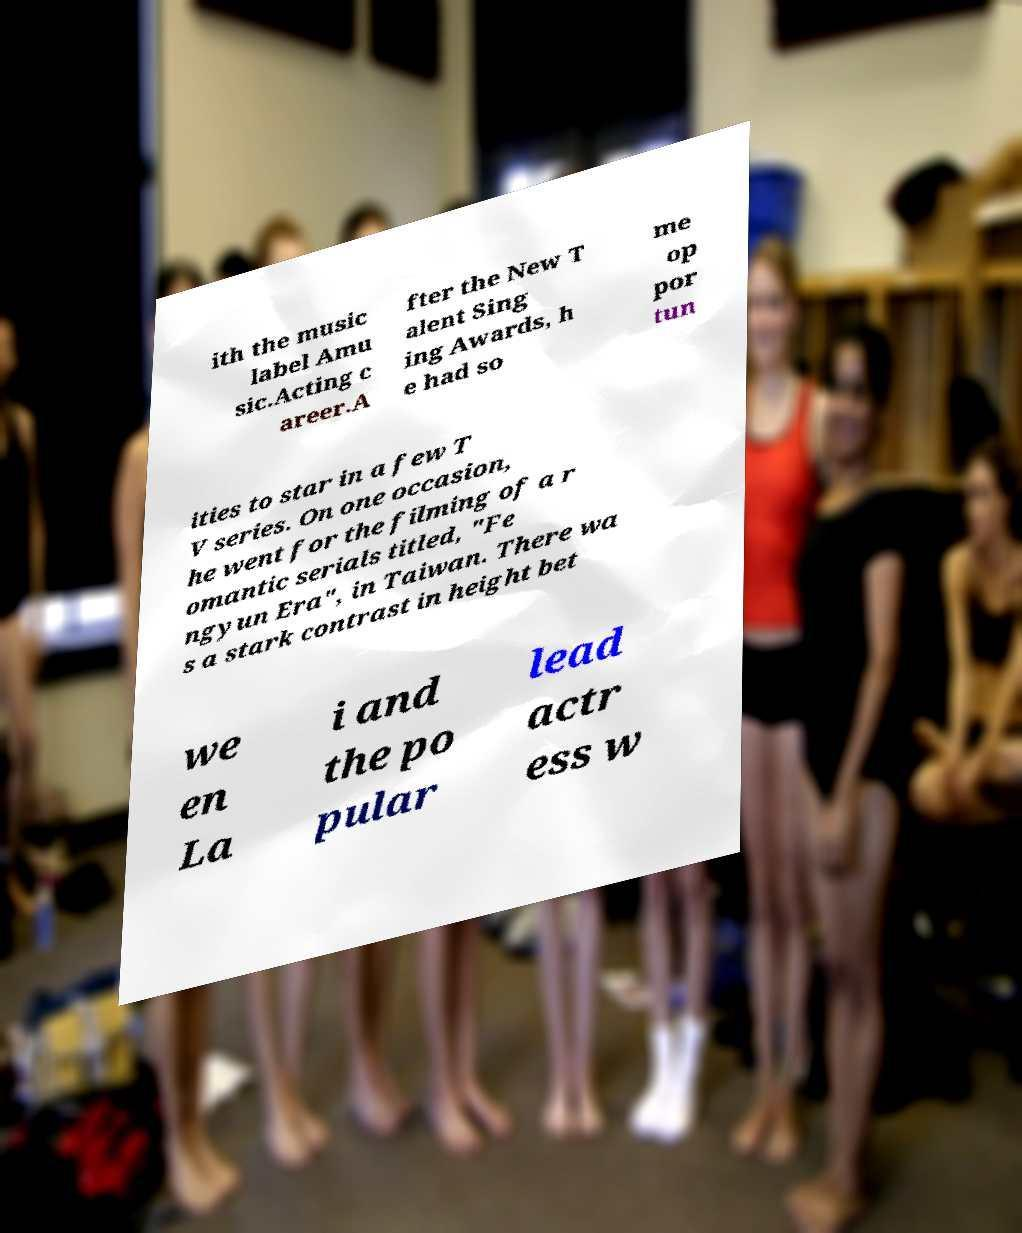Could you assist in decoding the text presented in this image and type it out clearly? ith the music label Amu sic.Acting c areer.A fter the New T alent Sing ing Awards, h e had so me op por tun ities to star in a few T V series. On one occasion, he went for the filming of a r omantic serials titled, "Fe ngyun Era", in Taiwan. There wa s a stark contrast in height bet we en La i and the po pular lead actr ess w 